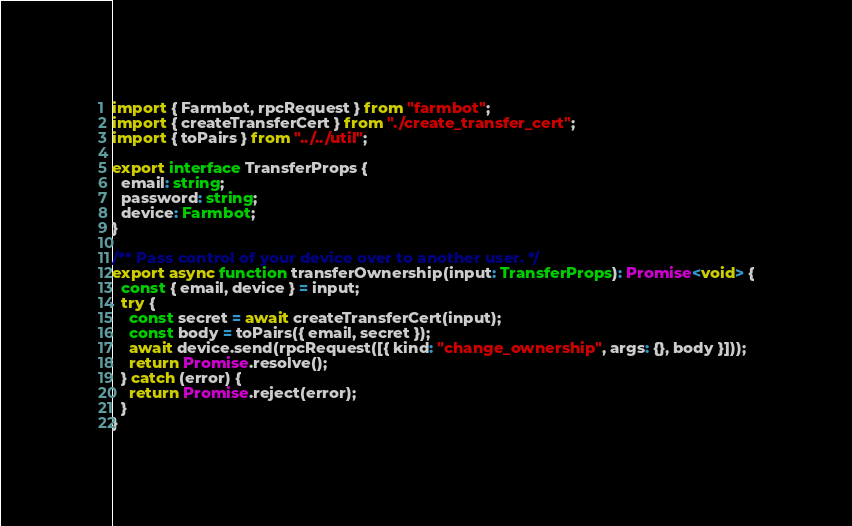Convert code to text. <code><loc_0><loc_0><loc_500><loc_500><_TypeScript_>import { Farmbot, rpcRequest } from "farmbot";
import { createTransferCert } from "./create_transfer_cert";
import { toPairs } from "../../util";

export interface TransferProps {
  email: string;
  password: string;
  device: Farmbot;
}

/** Pass control of your device over to another user. */
export async function transferOwnership(input: TransferProps): Promise<void> {
  const { email, device } = input;
  try {
    const secret = await createTransferCert(input);
    const body = toPairs({ email, secret });
    await device.send(rpcRequest([{ kind: "change_ownership", args: {}, body }]));
    return Promise.resolve();
  } catch (error) {
    return Promise.reject(error);
  }
}
</code> 